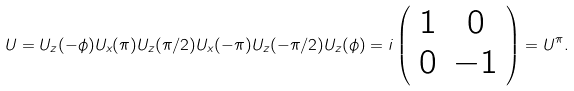Convert formula to latex. <formula><loc_0><loc_0><loc_500><loc_500>U = U _ { z } ( - \phi ) U _ { x } ( \pi ) U _ { z } ( \pi / 2 ) U _ { x } ( - \pi ) U _ { z } ( - \pi / 2 ) U _ { z } ( \phi ) = i \left ( \begin{array} { c c } 1 & 0 \\ 0 & - 1 \end{array} \right ) = U ^ { \pi } .</formula> 